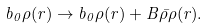<formula> <loc_0><loc_0><loc_500><loc_500>b _ { 0 } \rho ( r ) \rightarrow b _ { 0 } \rho ( r ) + B { \bar { \rho } } \rho ( r ) .</formula> 